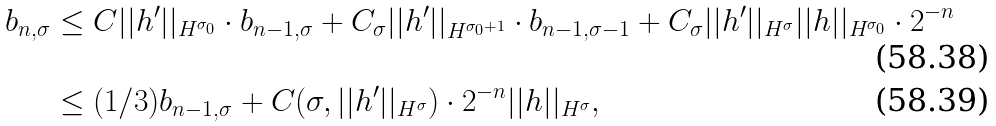<formula> <loc_0><loc_0><loc_500><loc_500>b _ { n , \sigma } & \leq C | | h ^ { \prime } | | _ { H ^ { \sigma _ { 0 } } } \cdot b _ { n - 1 , \sigma } + C _ { \sigma } | | h ^ { \prime } | | _ { H ^ { \sigma _ { 0 } + 1 } } \cdot b _ { n - 1 , \sigma - 1 } + C _ { \sigma } | | h ^ { \prime } | | _ { H ^ { \sigma } } | | h | | _ { H ^ { \sigma _ { 0 } } } \cdot 2 ^ { - n } \\ & \leq ( 1 / 3 ) b _ { n - 1 , \sigma } + C ( \sigma , | | h ^ { \prime } | | _ { H ^ { \sigma } } ) \cdot 2 ^ { - n } | | h | | _ { H ^ { \sigma } } ,</formula> 